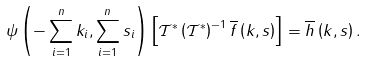<formula> <loc_0><loc_0><loc_500><loc_500>\psi \left ( - \sum _ { i = 1 } ^ { n } k _ { i } , \sum _ { i = 1 } ^ { n } s _ { i } \right ) \left [ \mathcal { T } ^ { * } \left ( \mathcal { T } ^ { * } \right ) ^ { - 1 } \overline { f } \left ( k , s \right ) \right ] = \overline { h } \left ( k , s \right ) .</formula> 